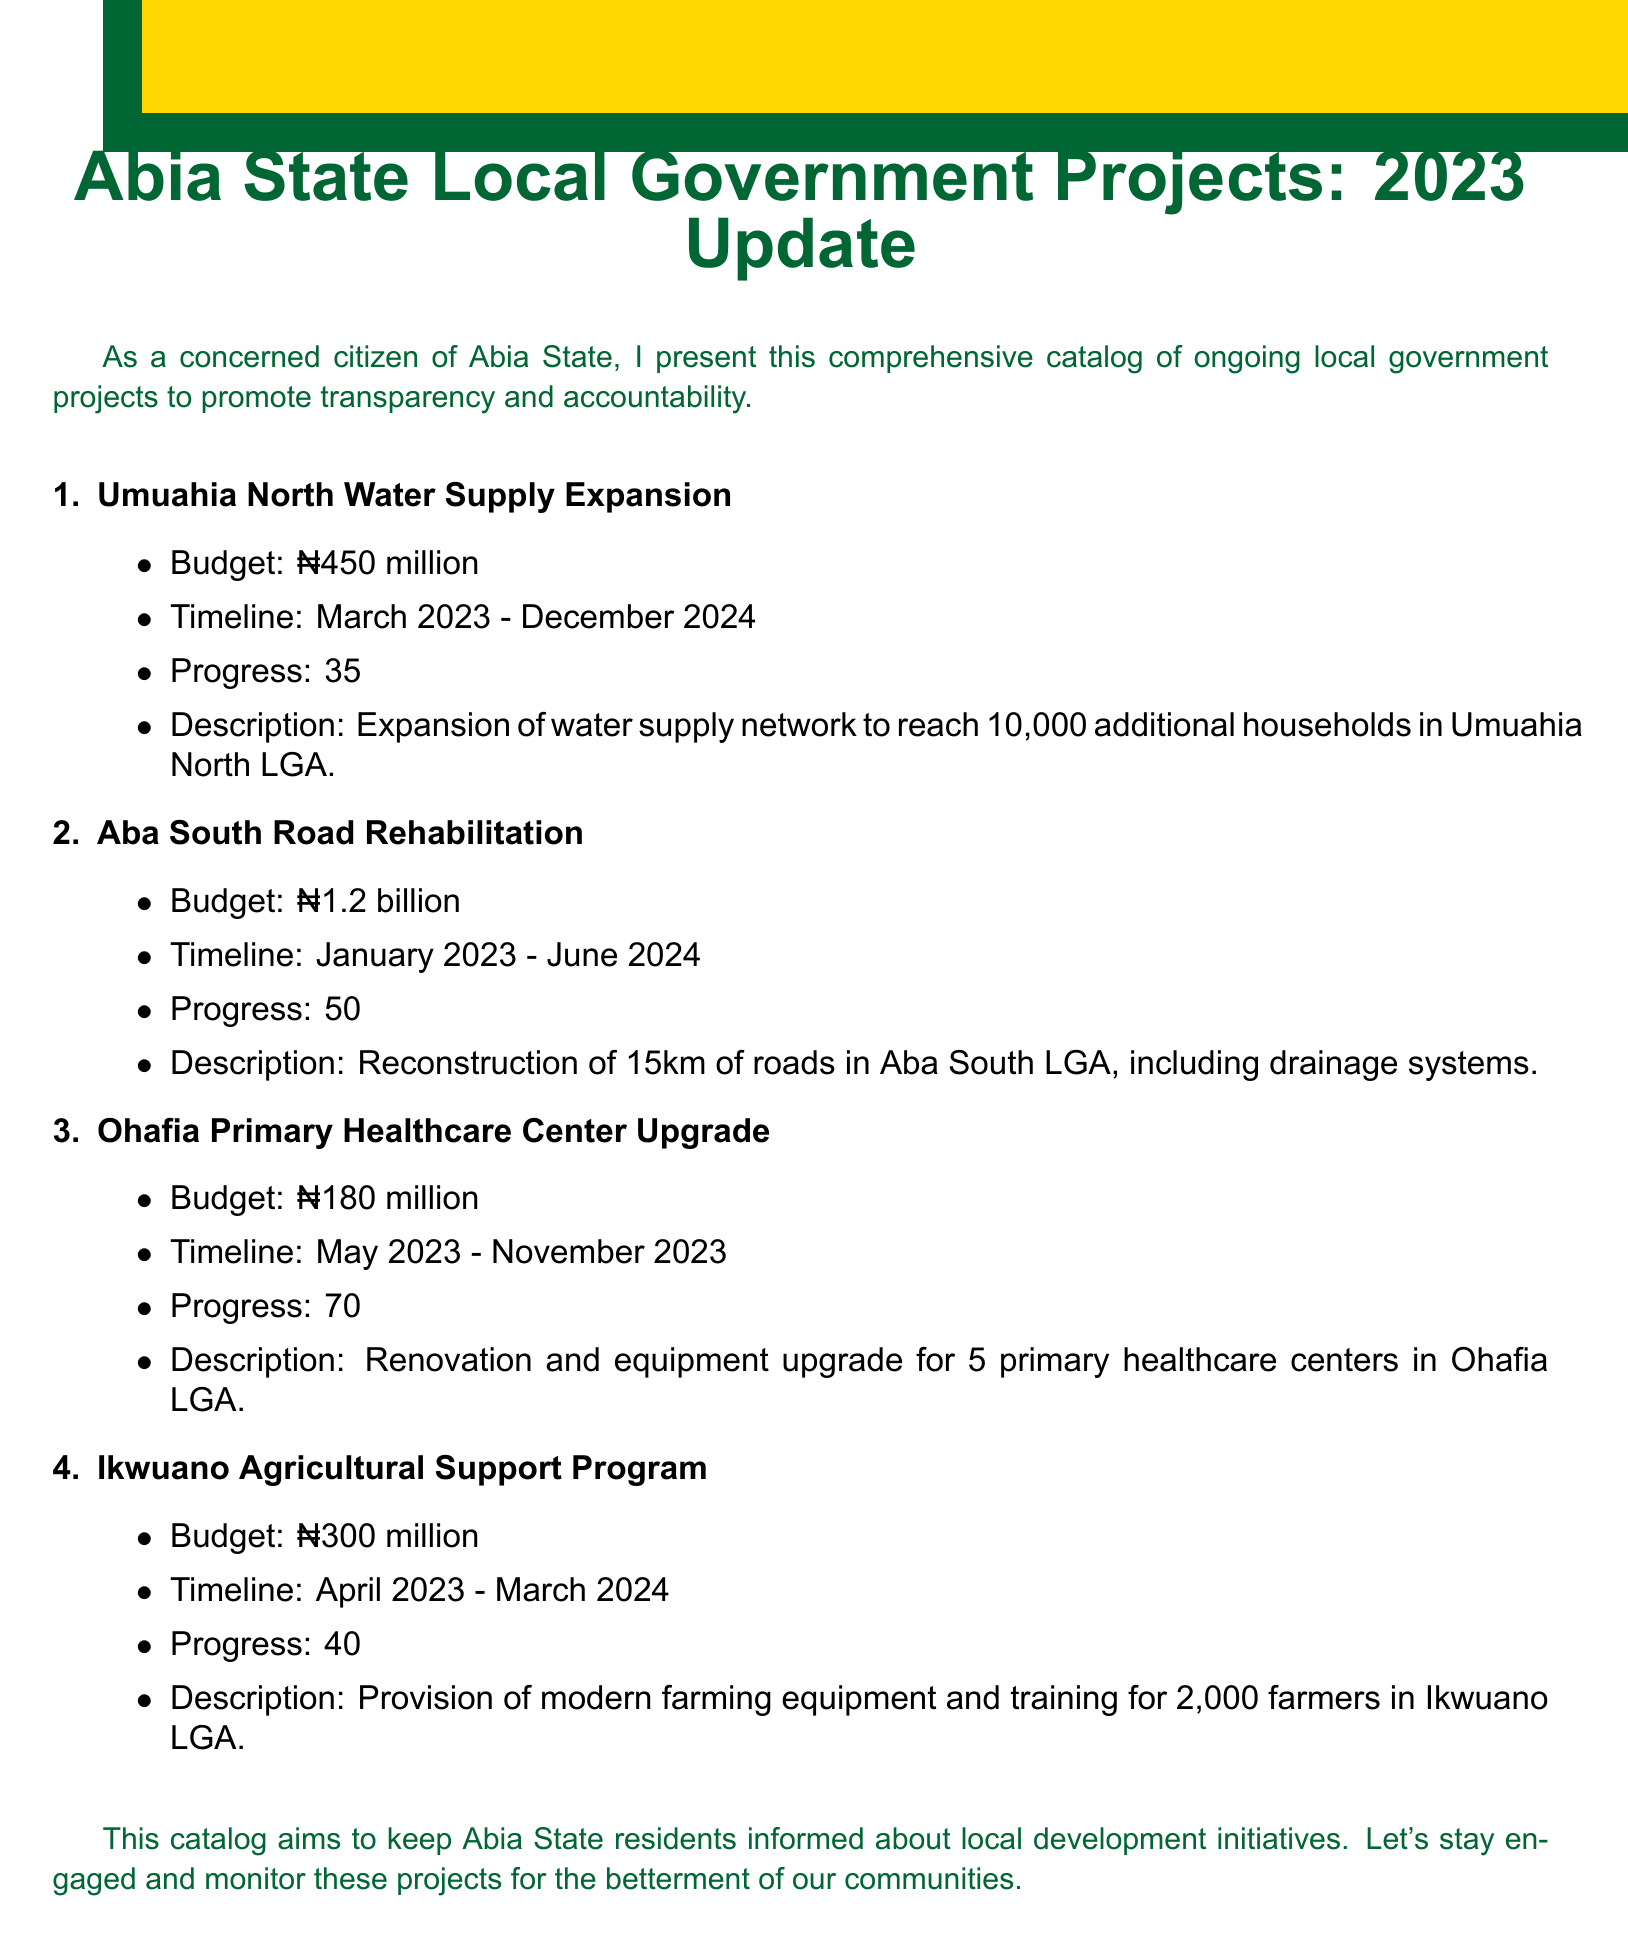What is the budget for the Umuahia North Water Supply Expansion? The budget is a specific piece of financial information for a project listed in the document.
Answer: ₦450 million What is the timeline for the Aba South Road Rehabilitation project? The timeline defines the duration in which the project is expected to be completed, as stated in the catalog.
Answer: January 2023 - June 2024 How much progress has been made on the Ohafia Primary Healthcare Center Upgrade? Progress percentage gives insight into how much of the project has been completed, according to the catalog.
Answer: 70% completed How many farmers are to benefit from the Ikwuano Agricultural Support Program? This number indicates the scale of the project's impact within the community, mentioned in the description.
Answer: 2,000 farmers What is the total budget for all listed projects? This requires summing the budgets of all projects for a comprehensive financial overview.
Answer: ₦2.13 billion Which local government area is targeted for the water supply expansion? The local government area identifies the geographical focus of a specific project in the document.
Answer: Umuahia North LGA What type of project is the Ohafia initiative? This identifies the nature of the project being discussed, relevant to community and health services.
Answer: Primary Healthcare Center Upgrade What is the main focus of the Ikwuano Agricultural Support Program? This question seeks to clarify the specific goal or outcome the project aims to achieve, as detailed in the document.
Answer: Provision of modern farming equipment and training 